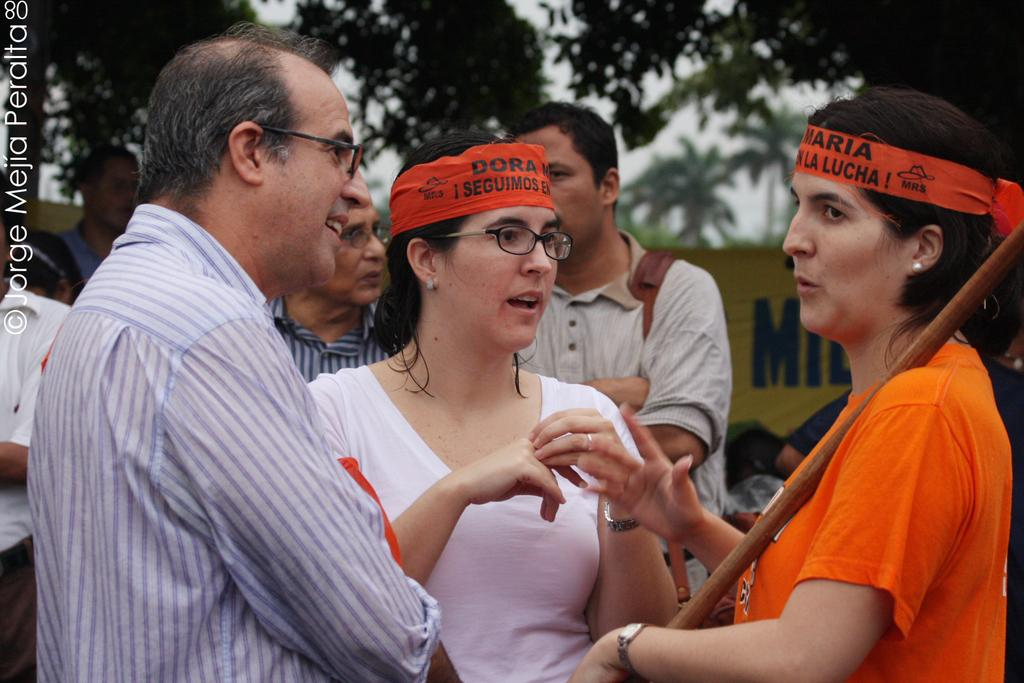What is happening in the middle of the image? There are people standing in the middle of the image. What is the facial expression of the people in the image? The people are smiling. What can be seen behind the people in the image? There is a banner behind the people. What type of natural scenery is visible in the image? Trees are visible at the top of the image. Can you see any dinosaurs roaming around in the image? No, there are no dinosaurs present in the image. What type of cast can be seen on the people's arms in the image? There is no cast visible on the people's arms in the image. 